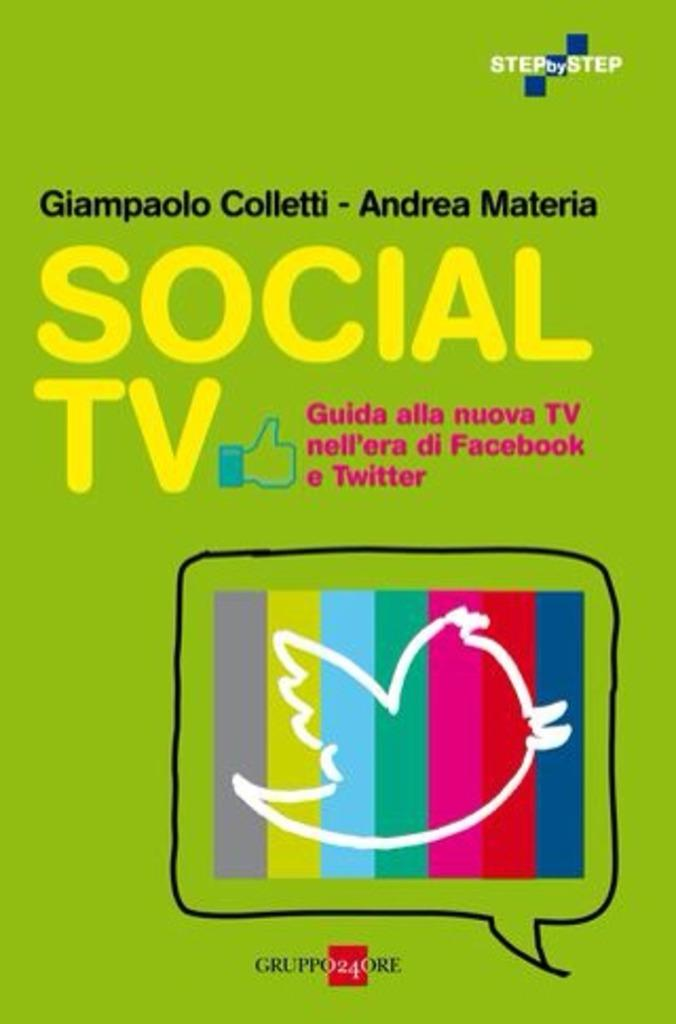<image>
Present a compact description of the photo's key features. An advertisement for Social TV by Step by Step. 